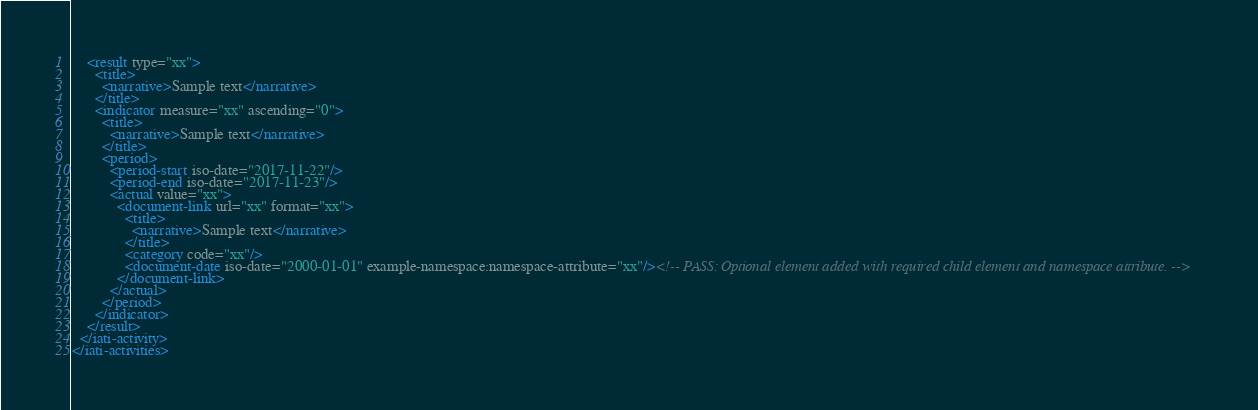Convert code to text. <code><loc_0><loc_0><loc_500><loc_500><_XML_>    <result type="xx">
      <title>
        <narrative>Sample text</narrative>
      </title>
      <indicator measure="xx" ascending="0">
        <title>
          <narrative>Sample text</narrative>
        </title>
        <period>
          <period-start iso-date="2017-11-22"/>
          <period-end iso-date="2017-11-23"/>
          <actual value="xx">
            <document-link url="xx" format="xx">
              <title>
                <narrative>Sample text</narrative>
              </title>
              <category code="xx"/>
              <document-date iso-date="2000-01-01" example-namespace:namespace-attribute="xx"/><!-- PASS: Optional element added with required child element and namespace attribute. -->
            </document-link>
          </actual>
        </period>
      </indicator>
    </result>
  </iati-activity>
</iati-activities>
</code> 